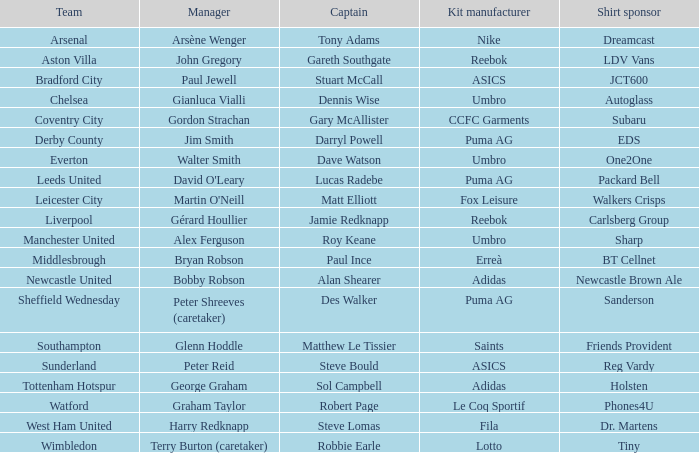Which equipment manufacturer sponsors arsenal? Nike. 